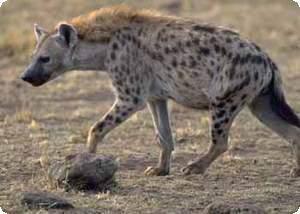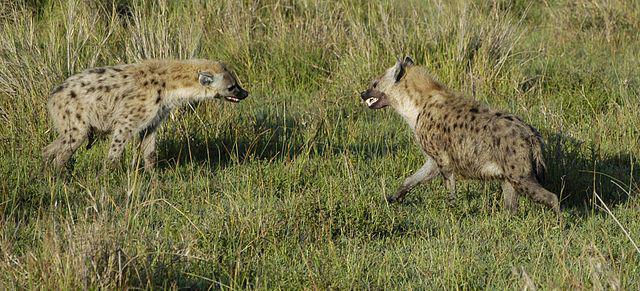The first image is the image on the left, the second image is the image on the right. Assess this claim about the two images: "Exactly one hyena is baring its fangs with wide-opened mouth, and no image shows hyenas posed face-to-face.". Correct or not? Answer yes or no. No. The first image is the image on the left, the second image is the image on the right. For the images displayed, is the sentence "Exactly one hyena's teeth are visible." factually correct? Answer yes or no. No. 